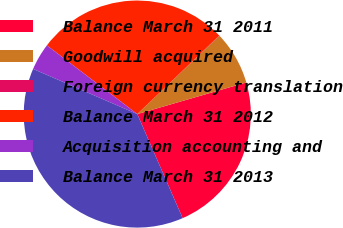Convert chart. <chart><loc_0><loc_0><loc_500><loc_500><pie_chart><fcel>Balance March 31 2011<fcel>Goodwill acquired<fcel>Foreign currency translation<fcel>Balance March 31 2012<fcel>Acquisition accounting and<fcel>Balance March 31 2013<nl><fcel>22.95%<fcel>7.63%<fcel>0.03%<fcel>27.51%<fcel>3.83%<fcel>38.05%<nl></chart> 